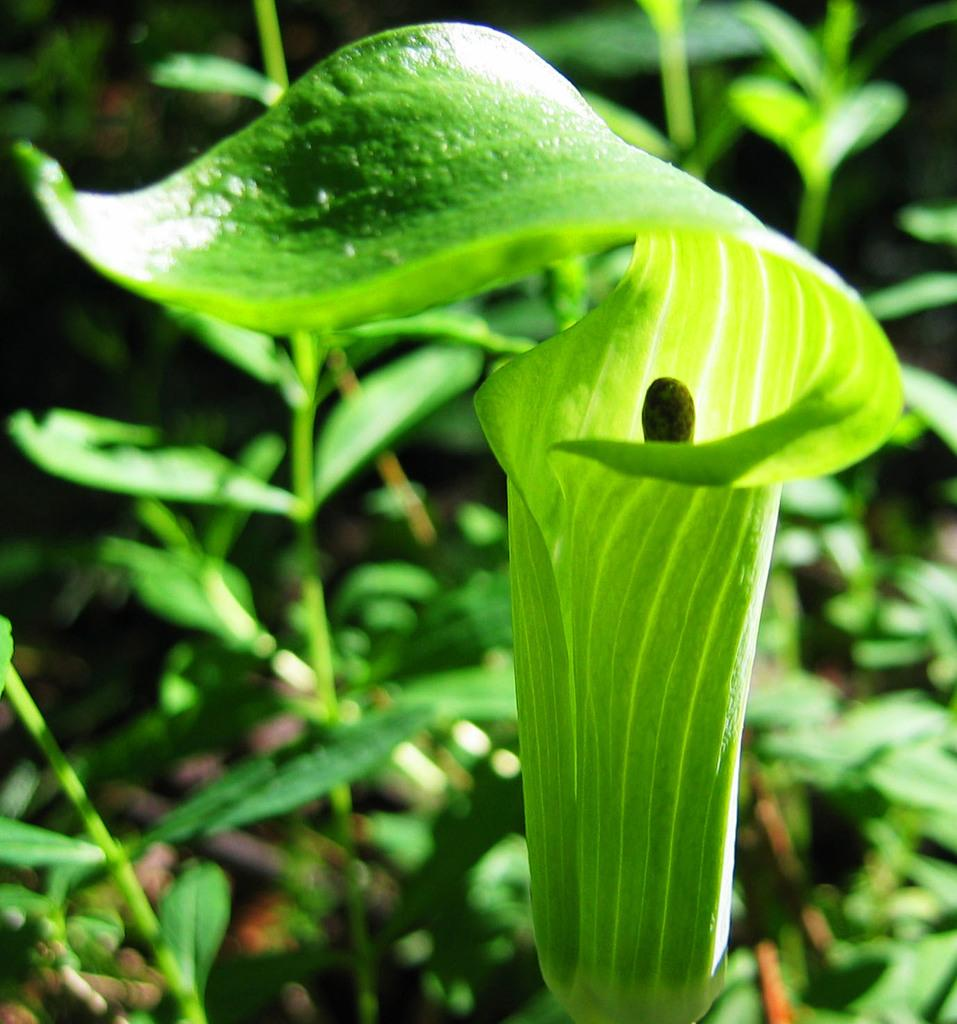What type of living organisms can be seen in the image? Plants can be seen in the image. What part of the plants is visible in the image? There are leaves visible in the image. What type of button can be seen on the plants in the image? There is no button present on the plants in the image. Can you see any clouds in the image? There is no mention of clouds in the provided facts, and therefore it cannot be determined if clouds are present in the image. 